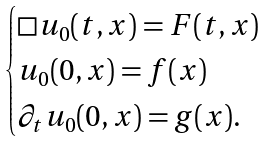<formula> <loc_0><loc_0><loc_500><loc_500>\begin{cases} \Box u _ { 0 } ( t , x ) = F ( t , x ) \\ u _ { 0 } ( 0 , x ) = f ( x ) \\ \partial _ { t } u _ { 0 } ( 0 , x ) = g ( x ) . \end{cases}</formula> 